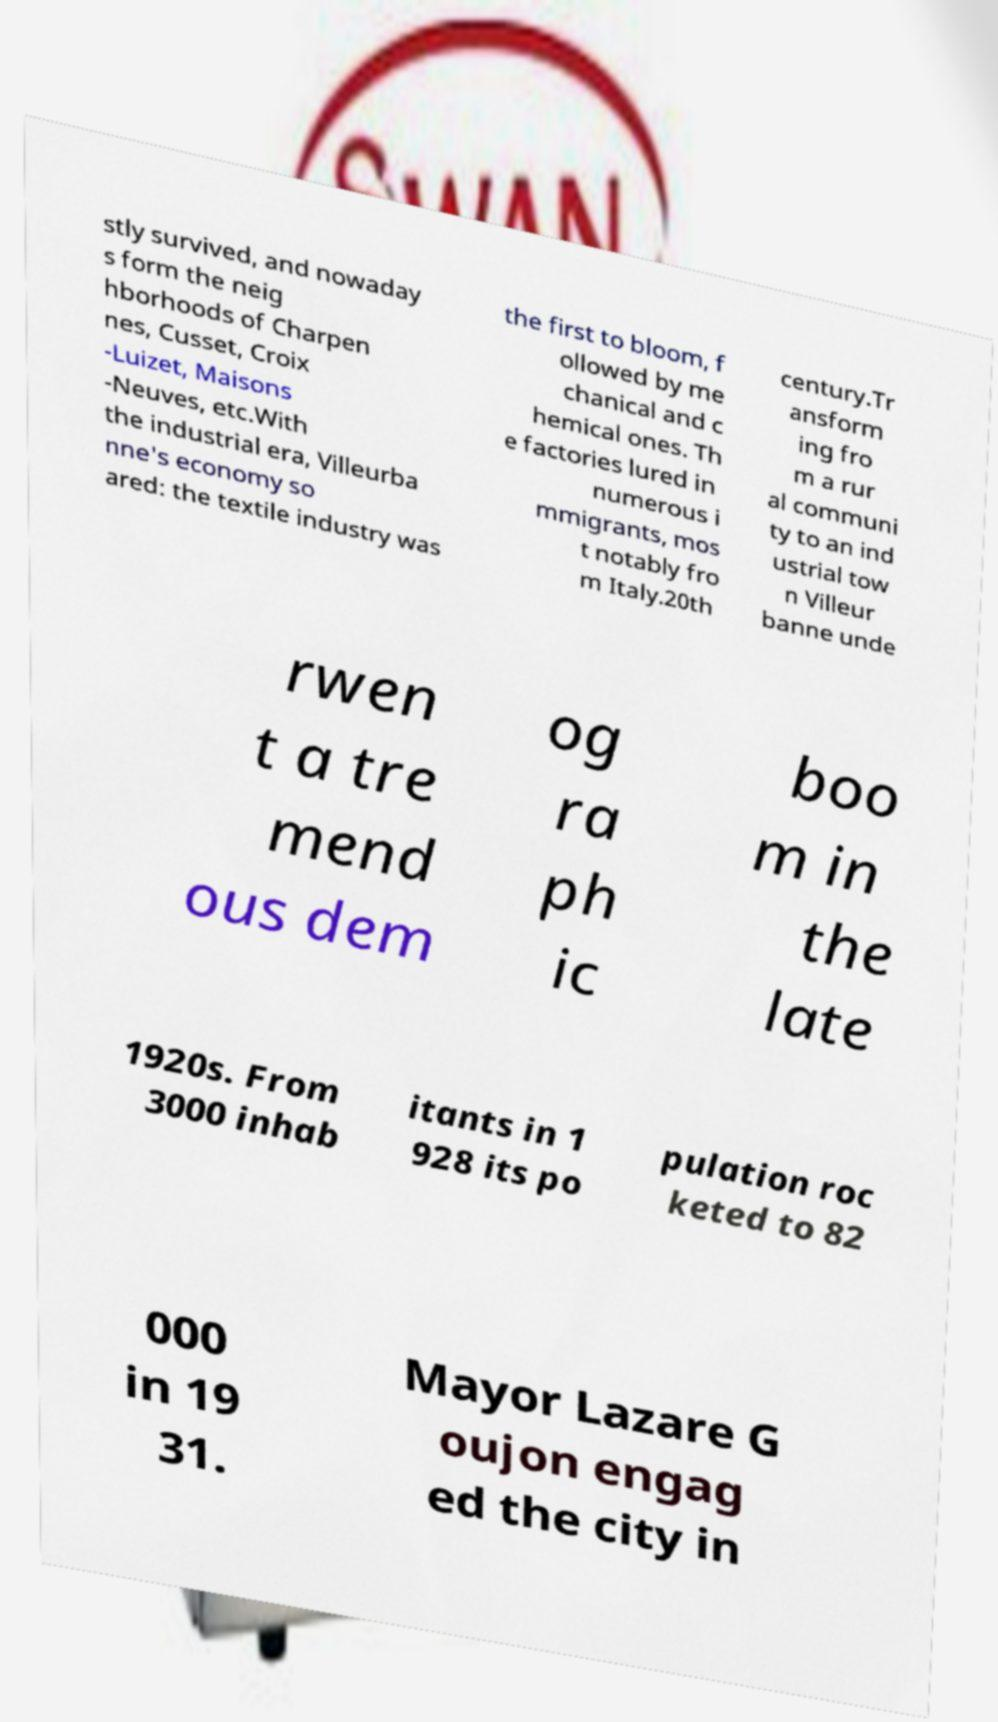There's text embedded in this image that I need extracted. Can you transcribe it verbatim? stly survived, and nowaday s form the neig hborhoods of Charpen nes, Cusset, Croix -Luizet, Maisons -Neuves, etc.With the industrial era, Villeurba nne's economy so ared: the textile industry was the first to bloom, f ollowed by me chanical and c hemical ones. Th e factories lured in numerous i mmigrants, mos t notably fro m Italy.20th century.Tr ansform ing fro m a rur al communi ty to an ind ustrial tow n Villeur banne unde rwen t a tre mend ous dem og ra ph ic boo m in the late 1920s. From 3000 inhab itants in 1 928 its po pulation roc keted to 82 000 in 19 31. Mayor Lazare G oujon engag ed the city in 